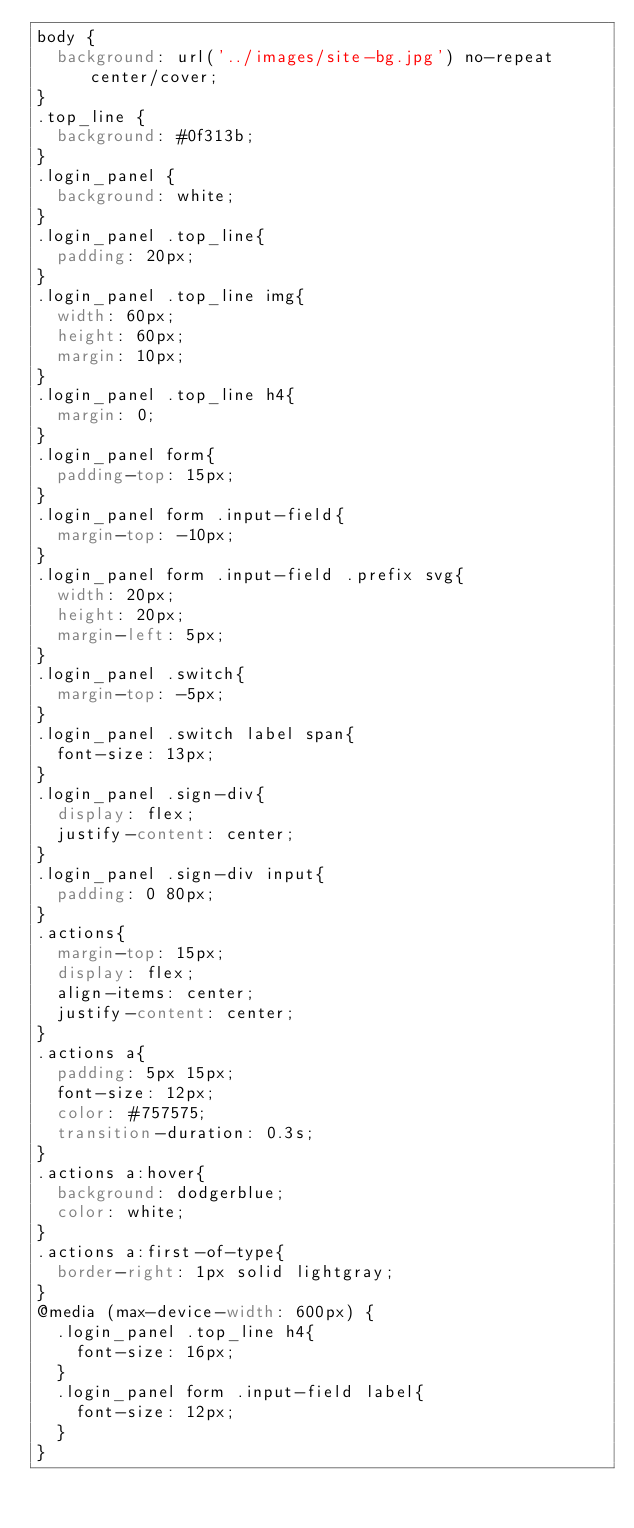<code> <loc_0><loc_0><loc_500><loc_500><_CSS_>body {
  background: url('../images/site-bg.jpg') no-repeat center/cover;
}
.top_line {
  background: #0f313b;
}
.login_panel {
  background: white;
}
.login_panel .top_line{
  padding: 20px;
}
.login_panel .top_line img{
  width: 60px;
  height: 60px;
  margin: 10px;
}
.login_panel .top_line h4{
  margin: 0;
}
.login_panel form{
  padding-top: 15px;
}
.login_panel form .input-field{
  margin-top: -10px;
}
.login_panel form .input-field .prefix svg{
  width: 20px;
  height: 20px;
  margin-left: 5px;
}
.login_panel .switch{
  margin-top: -5px;
}
.login_panel .switch label span{
  font-size: 13px;
}
.login_panel .sign-div{
  display: flex;
  justify-content: center;
}
.login_panel .sign-div input{
  padding: 0 80px;
}
.actions{
  margin-top: 15px;
  display: flex;
  align-items: center;
  justify-content: center;
}
.actions a{
  padding: 5px 15px;
  font-size: 12px;
  color: #757575;
  transition-duration: 0.3s;
}
.actions a:hover{
  background: dodgerblue;
  color: white;
}
.actions a:first-of-type{
  border-right: 1px solid lightgray;
}
@media (max-device-width: 600px) {
  .login_panel .top_line h4{
    font-size: 16px;
  }
  .login_panel form .input-field label{
    font-size: 12px;
  }
}</code> 